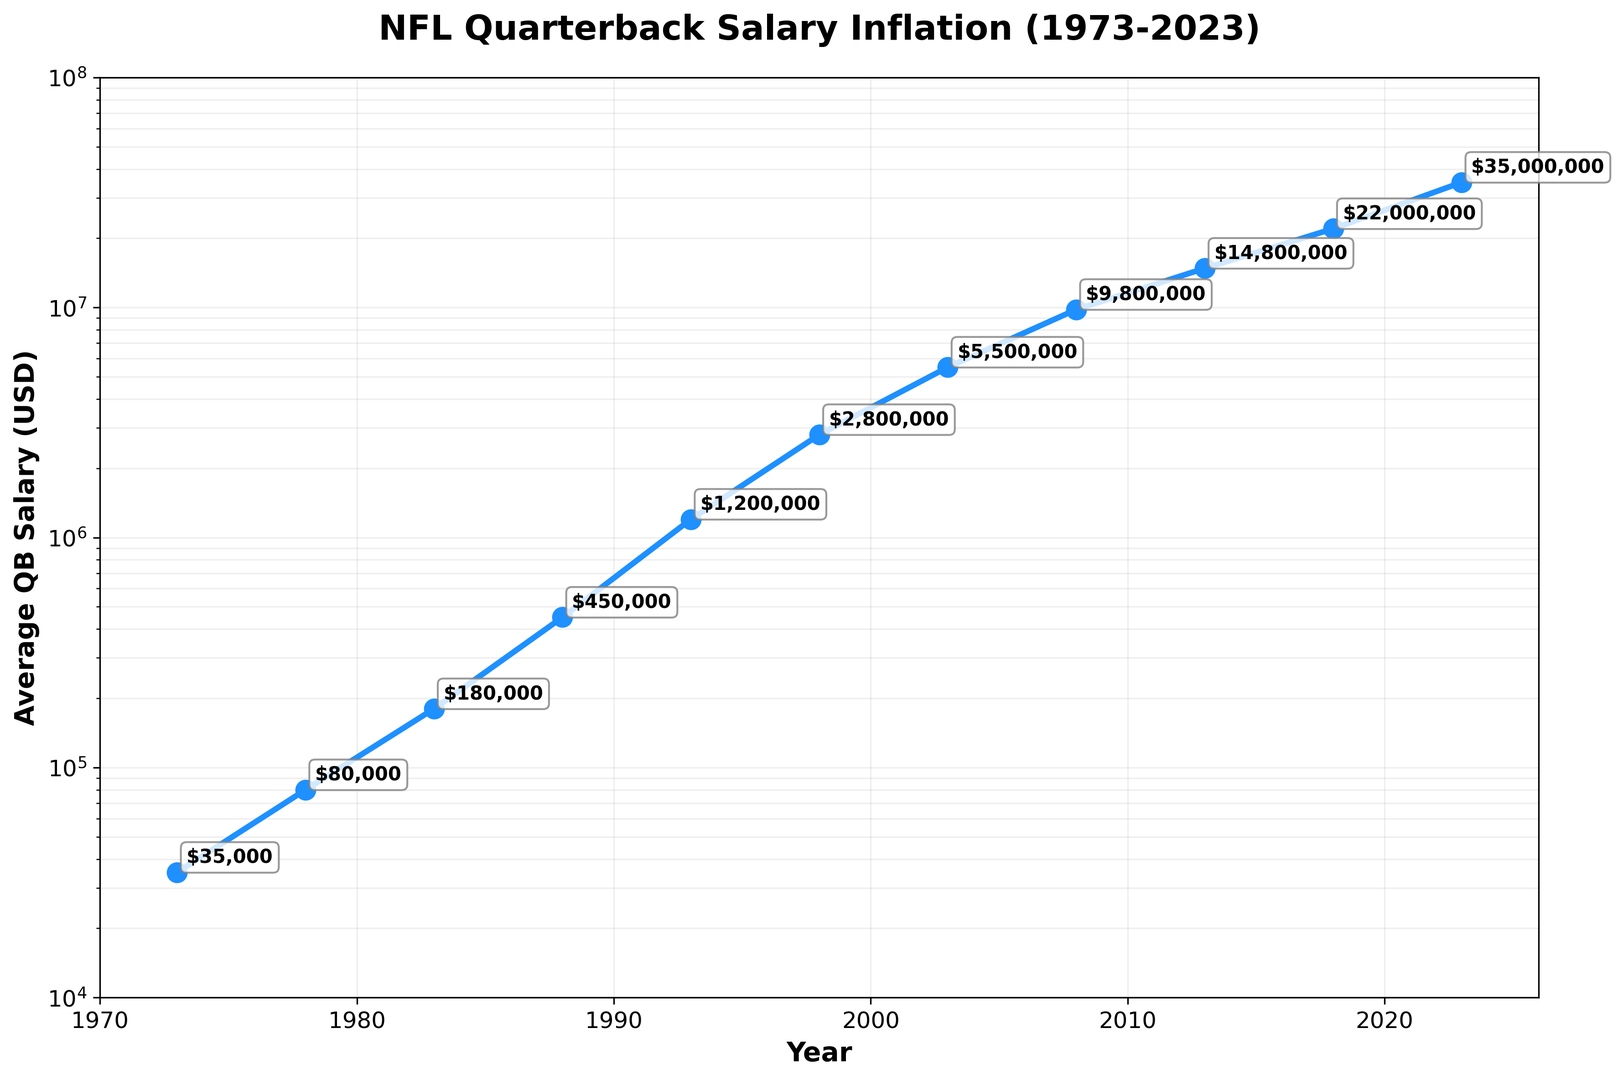Which year shows the highest average QB salary? The figure indicates the data values for each year. The last point at 2023 has the highest value annotated as $35,000,000.
Answer: 2023 How much did the average QB salary increase from 1973 to 2023? The salary in 1973 is $35,000 and in 2023 is $35,000,000. Subtract the 1973 value from the 2023 value: $35,000,000 - $35,000 = $34,965,000.
Answer: $34,965,000 Between which consecutive years did the average QB salary increase the most? Examine the annotated values to find the pairs of consecutive years with the largest difference. The largest increase is from 2018 ($22,000,000) to 2023 ($35,000,000), which is an increase of $13,000,000.
Answer: 2018 to 2023 By what factor did the average QB salary multiply from 1983 to 2003? The salary in 1983 is $180,000, and in 2003 it is $5,500,000. Divide the 2003 value by the 1983 value: $5,500,000 / $180,000 = 30.56.
Answer: 30.56 What is the average QB salary across all the marked years? Sum all the salaries and divide by the number of years: (35000 + 80000 + 180000 + 450000 + 1200000 + 2800000 + 5500000 + 9800000 + 14800000 + 22000000 + 35000000) / 11 = $8,186,364.
Answer: $8,186,364 Which year saw the first average QB salary crossing the $1 million mark? The figure shows 1993 has the first average salary above $1 million with an annotation of $1,200,000.
Answer: 1993 What was the average annual growth rate in salary from 1973 to 2023? Use the formula for CAGR: [(Final Value / Initial Value) ^ (1 / Number of Periods)] - 1. Initial value = $35,000, final value = $35,000,000, and years = 2023-1973 = 50. CAGR = [($35,000,000 / $35,000) ^ (1 / 50)] - 1 = 0.17 or 17%.
Answer: 17% How much did the average QB salary increase from 1988 to 1993? The salary in 1988 is $450,000 and in 1993 is $1,200,000. Subtract the 1988 value from the 1993 value: $1,200,000 - $450,000 = $750,000.
Answer: $750,000 Compare the average QB salary in 1978 and 2013. By what multiple did it increase? The salary in 1978 is $80,000, and in 2013 it is $14,800,000. Divide the 2013 value by the 1978 value: $14,800,000 / $80,000 = 185.
Answer: 185 